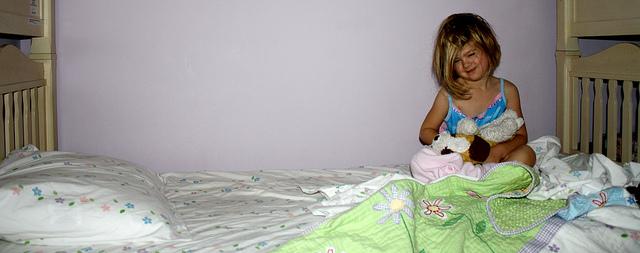What specific kind of bed is this?
Concise answer only. Bunk bed. Is the little girl tired?
Short answer required. Yes. What color is the wall?
Quick response, please. White. 